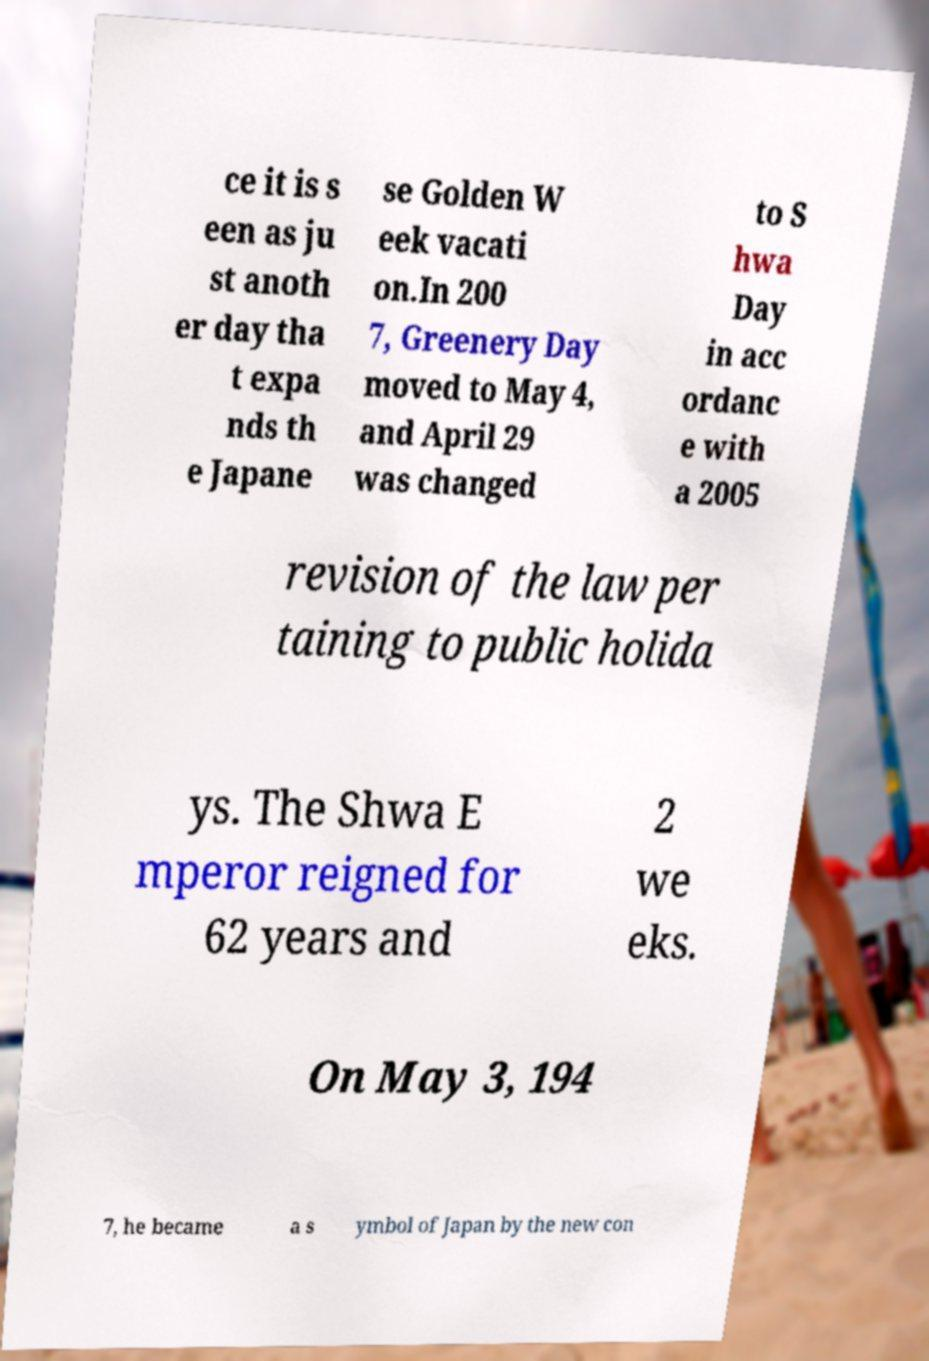For documentation purposes, I need the text within this image transcribed. Could you provide that? ce it is s een as ju st anoth er day tha t expa nds th e Japane se Golden W eek vacati on.In 200 7, Greenery Day moved to May 4, and April 29 was changed to S hwa Day in acc ordanc e with a 2005 revision of the law per taining to public holida ys. The Shwa E mperor reigned for 62 years and 2 we eks. On May 3, 194 7, he became a s ymbol of Japan by the new con 